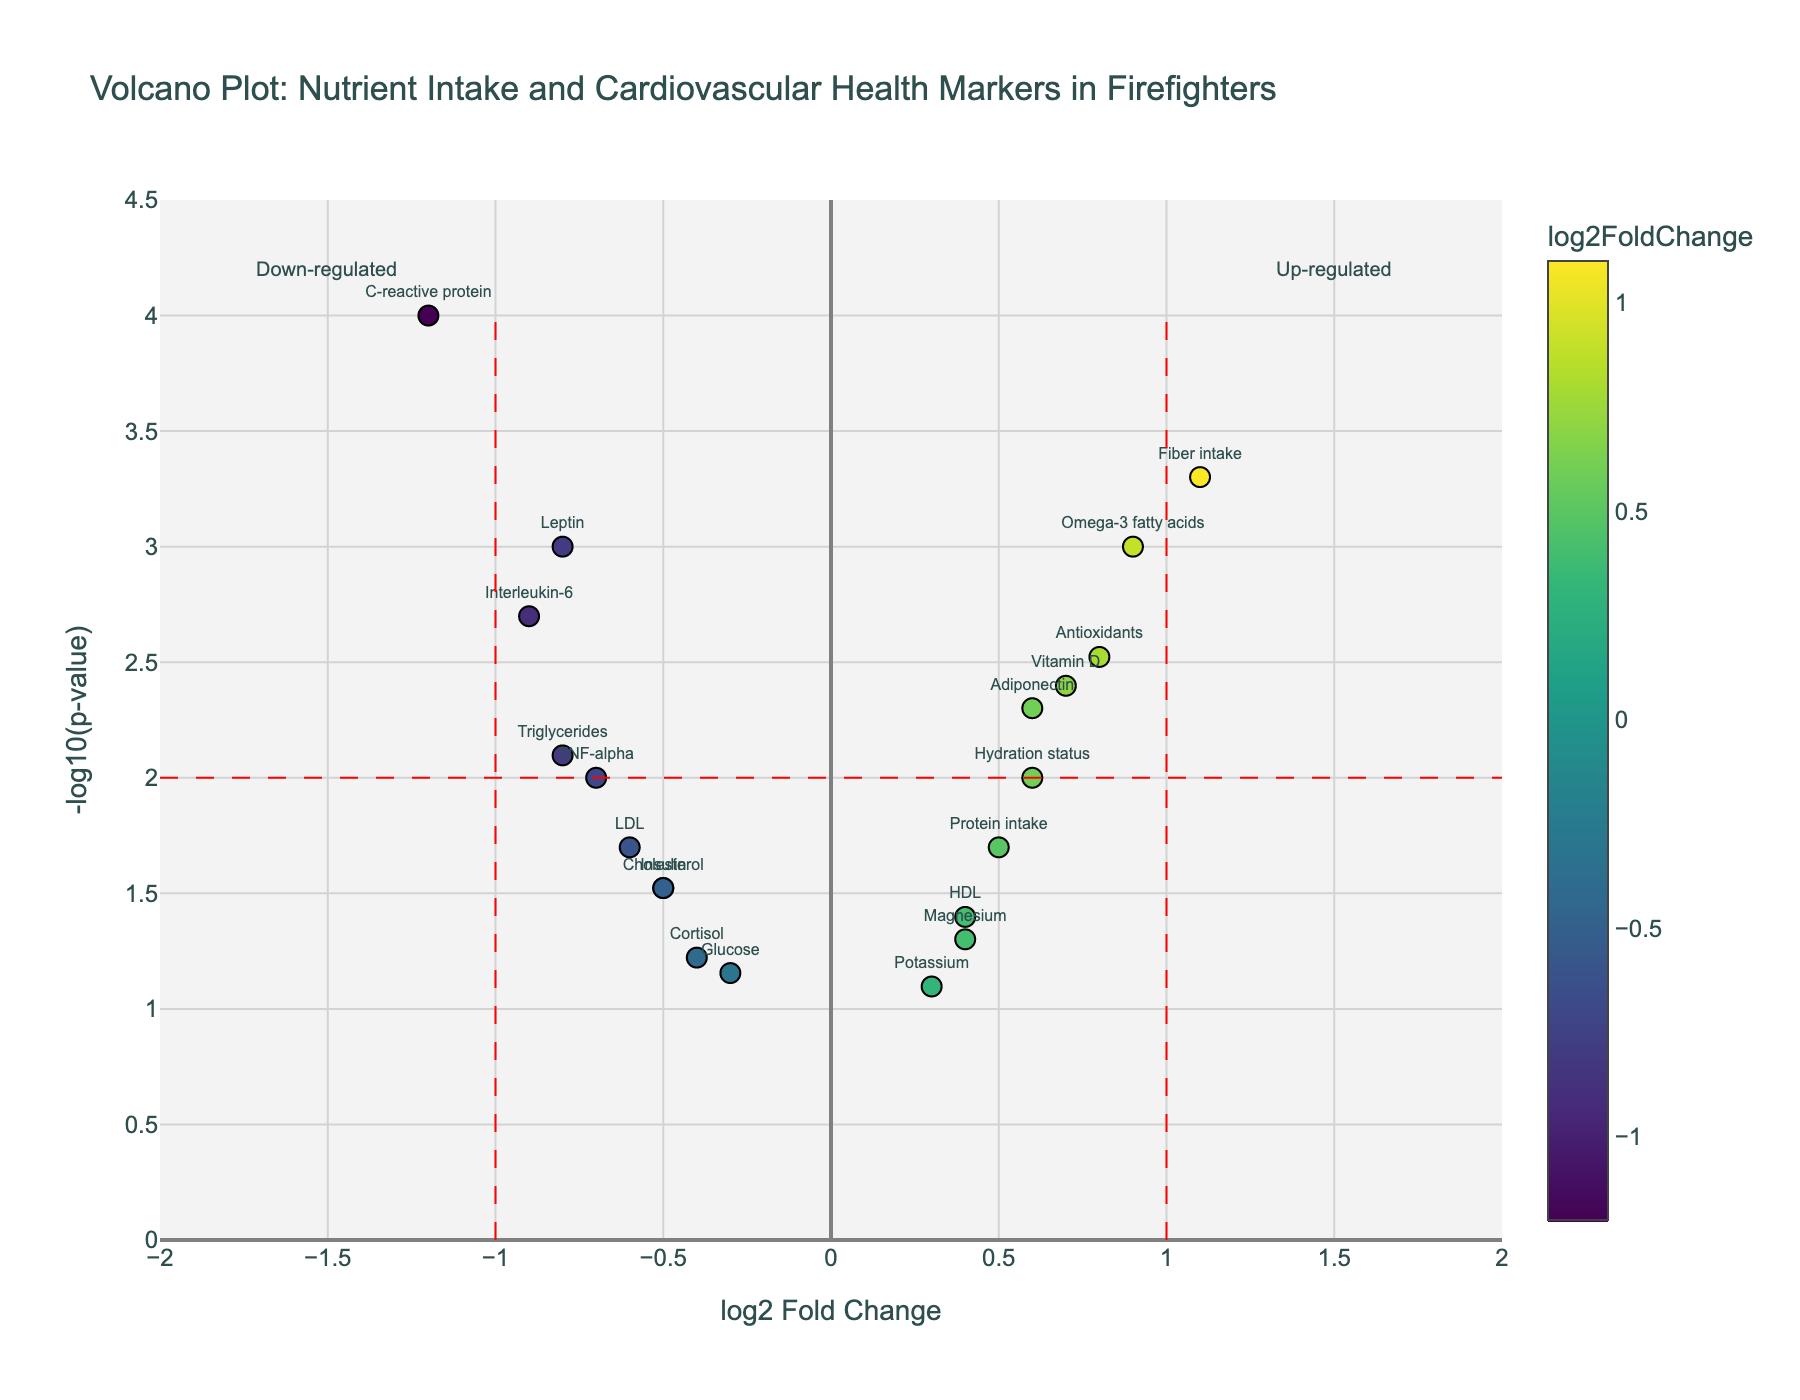What is the title of the plot? The title is located at the top of the plot and provides a general description of the data being visualized.
Answer: Volcano Plot: Nutrient Intake and Cardiovascular Health Markers in Firefighters Which axis represents the log2 fold change? The x-axis represents the log2 fold change, as indicated by the label "log2 Fold Change" below the horizontal axis.
Answer: x-axis What is represented by the y-axis in the plot? The y-axis represents the -log10(p-value), as indicated by the label "-log10(p-value)" along the vertical axis.
Answer: -log10(p-value) How many genes have a log2 fold change greater than 0.5? Count the number of data points (markers) positioned to the right of 0.5 on the x-axis. Specifically, Vitamin D, Omega-3 fatty acids, Antioxidants, Fiber intake, Protein intake, and Hydration status.
Answer: 6 Which nutrient shows the most significant increase after implementing the specialized diet? The significance can be measured by the highest value on the y-axis in the positive range of the x-axis (log2 fold change). Omega-3 fatty acids have the highest -log10(p-value) among the positively classified nutrients (log2 fold change of 0.9 and p-value of 0.001).
Answer: Omega-3 fatty acids Which cardiovascular health marker experienced the largest decrease? Look for the gene with the most negative value on the x-axis (log2 fold change) with a significant p-value. C-reactive protein has a log2 fold change of -1.2 and a p-value of 0.0001.
Answer: C-reactive protein How many points are above the line representing p = 0.01? Identify and count the markers with -log10(p-value) larger than 2, as -log10(0.01) equals 2. This includes Leptin, Adiponectin, C-reactive protein, Interleukin-6, TNF-alpha, Triglycerides, Vitamin D, Omega-3 fatty acids, Antioxidants, and Fiber intake.
Answer: 10 Which genes are both up-regulated and significant? Examine the points with positive log2 fold change (up-regulation) and those with significant p-values (typically considered below 0.05, hence larger than -log10(0.05)). Relevant genes are Adiponectin, Vitamin D, Omega-3 fatty acids, Antioxidants, Fiber intake, and Hydration status.
Answer: Adiponectin, Vitamin D, Omega-3 fatty acids, Antioxidants, Fiber intake, Hydration status What is the range of log2 fold change covered in the plot? Look at the extent of the x-axis to see the lowest and highest log2 fold changes displayed. The plot ranges from -2 to 2.
Answer: -2 to 2 Between LDL and HDL, which showed a greater change in log2 fold change? Compare the absolute values of their log2 fold changes. LDL has a log2 fold change of -0.6 while HDL has a log2 fold change of 0.4. LDL shows a greater change in terms of absolute value.
Answer: LDL 